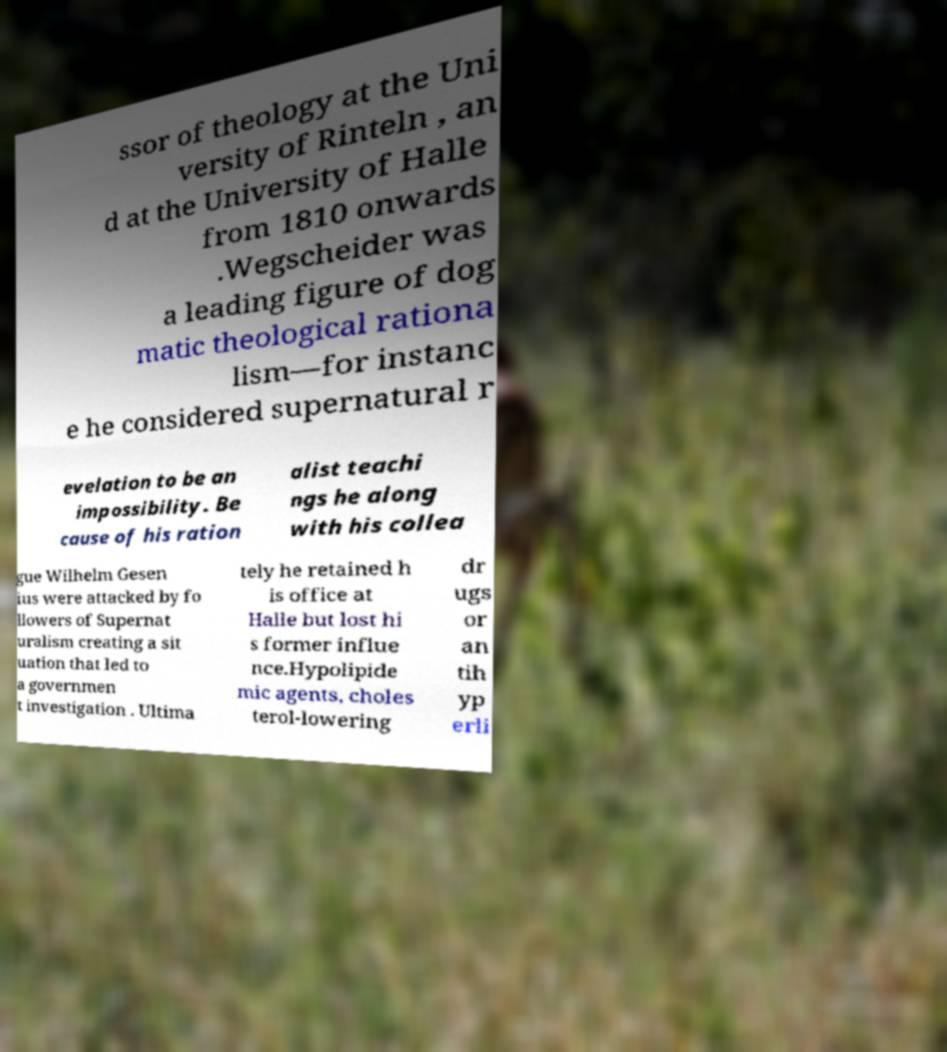Can you accurately transcribe the text from the provided image for me? ssor of theology at the Uni versity of Rinteln , an d at the University of Halle from 1810 onwards .Wegscheider was a leading figure of dog matic theological rationa lism—for instanc e he considered supernatural r evelation to be an impossibility. Be cause of his ration alist teachi ngs he along with his collea gue Wilhelm Gesen ius were attacked by fo llowers of Supernat uralism creating a sit uation that led to a governmen t investigation . Ultima tely he retained h is office at Halle but lost hi s former influe nce.Hypolipide mic agents, choles terol-lowering dr ugs or an tih yp erli 